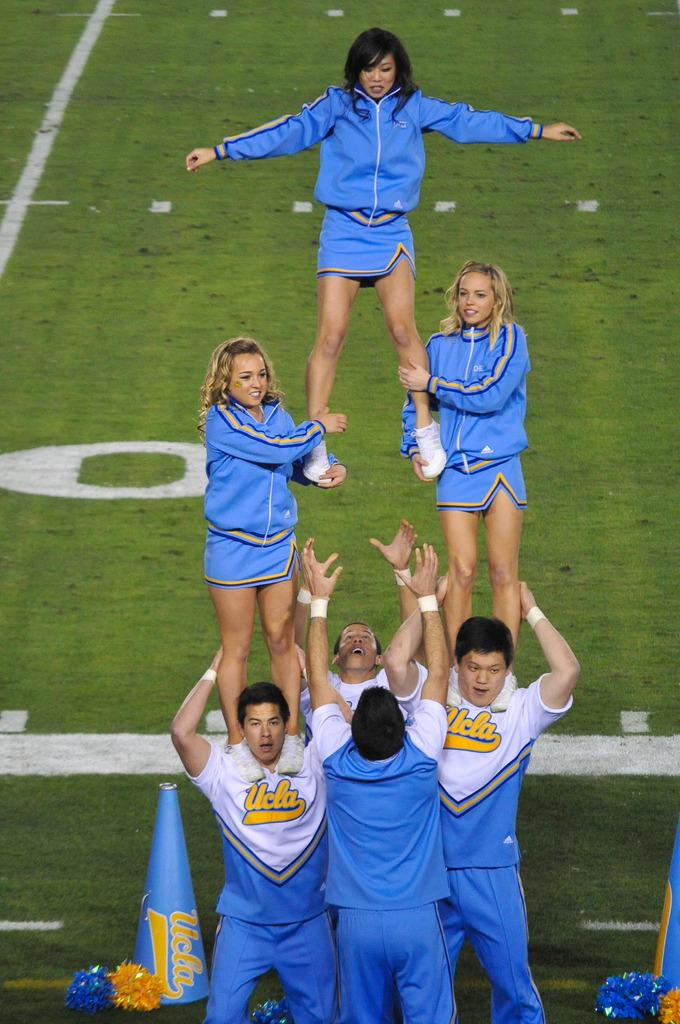<image>
Render a clear and concise summary of the photo. UCLA male cheerleaders hold 2 levels of women cheerleaders above them in a stunt. 